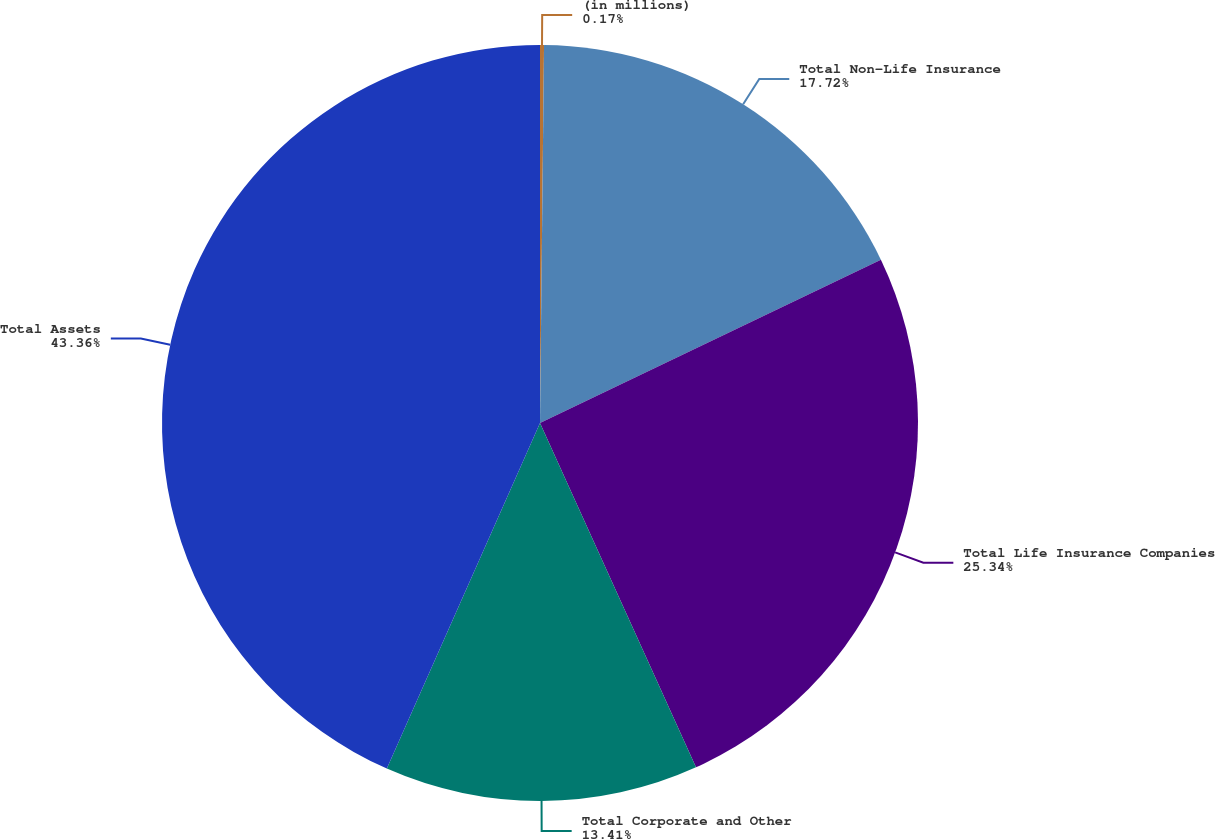Convert chart to OTSL. <chart><loc_0><loc_0><loc_500><loc_500><pie_chart><fcel>(in millions)<fcel>Total Non-Life Insurance<fcel>Total Life Insurance Companies<fcel>Total Corporate and Other<fcel>Total Assets<nl><fcel>0.17%<fcel>17.72%<fcel>25.34%<fcel>13.41%<fcel>43.36%<nl></chart> 